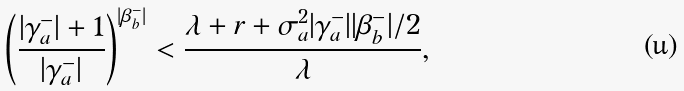<formula> <loc_0><loc_0><loc_500><loc_500>\left ( \frac { | \gamma ^ { - } _ { a } | + 1 } { | \gamma ^ { - } _ { a } | } \right ) ^ { | \beta ^ { - } _ { b } | } < \frac { \lambda + r + \sigma ^ { 2 } _ { a } | \gamma ^ { - } _ { a } | | \beta ^ { - } _ { b } | / 2 } { \lambda } ,</formula> 